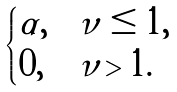<formula> <loc_0><loc_0><loc_500><loc_500>\begin{cases} \alpha , & \nu \leq 1 , \\ 0 , & \nu > 1 . \end{cases}</formula> 